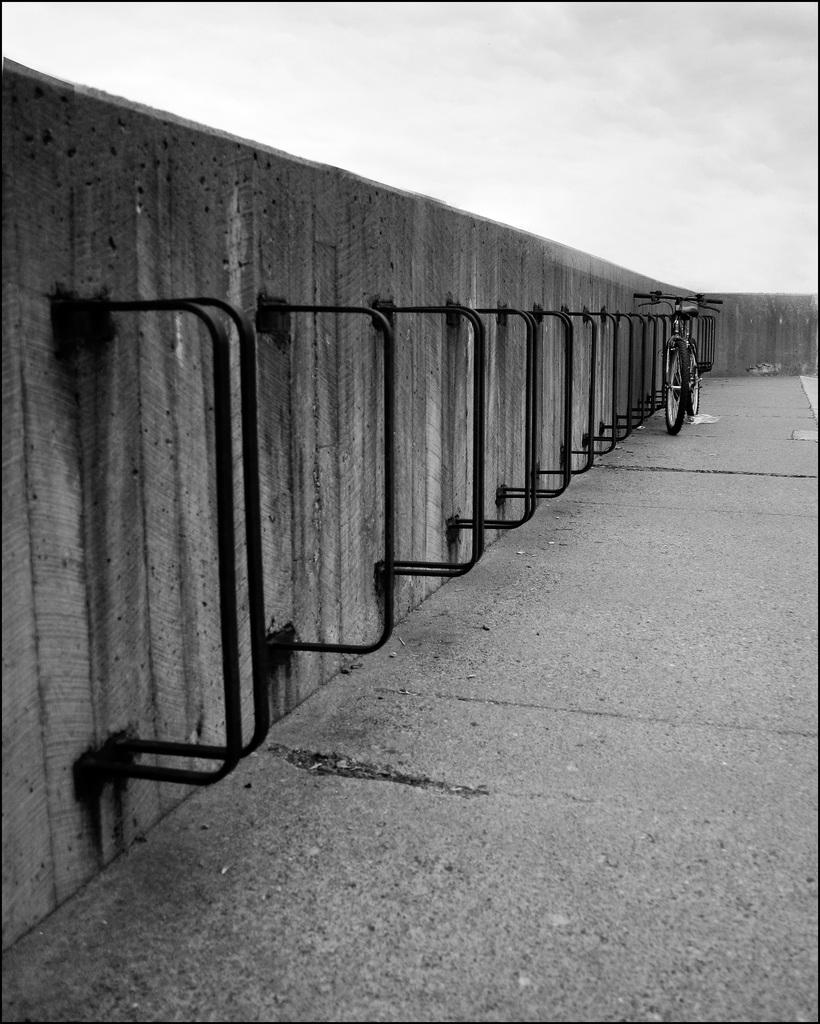What is the color scheme of the image? The image is black and white. What can be seen in the image besides the color scheme? There is a cycle in the image. Where is the cycle located in relation to other objects? The cycle is beside a wall. What is visible at the top of the image? The sky is visible at the top of the image. Where is the secretary sitting in the image? There is no secretary present in the image; it features a cycle beside a wall. What type of berry can be seen growing on the wall in the image? There are no berries visible in the image; it is a black and white image featuring a cycle beside a wall. 